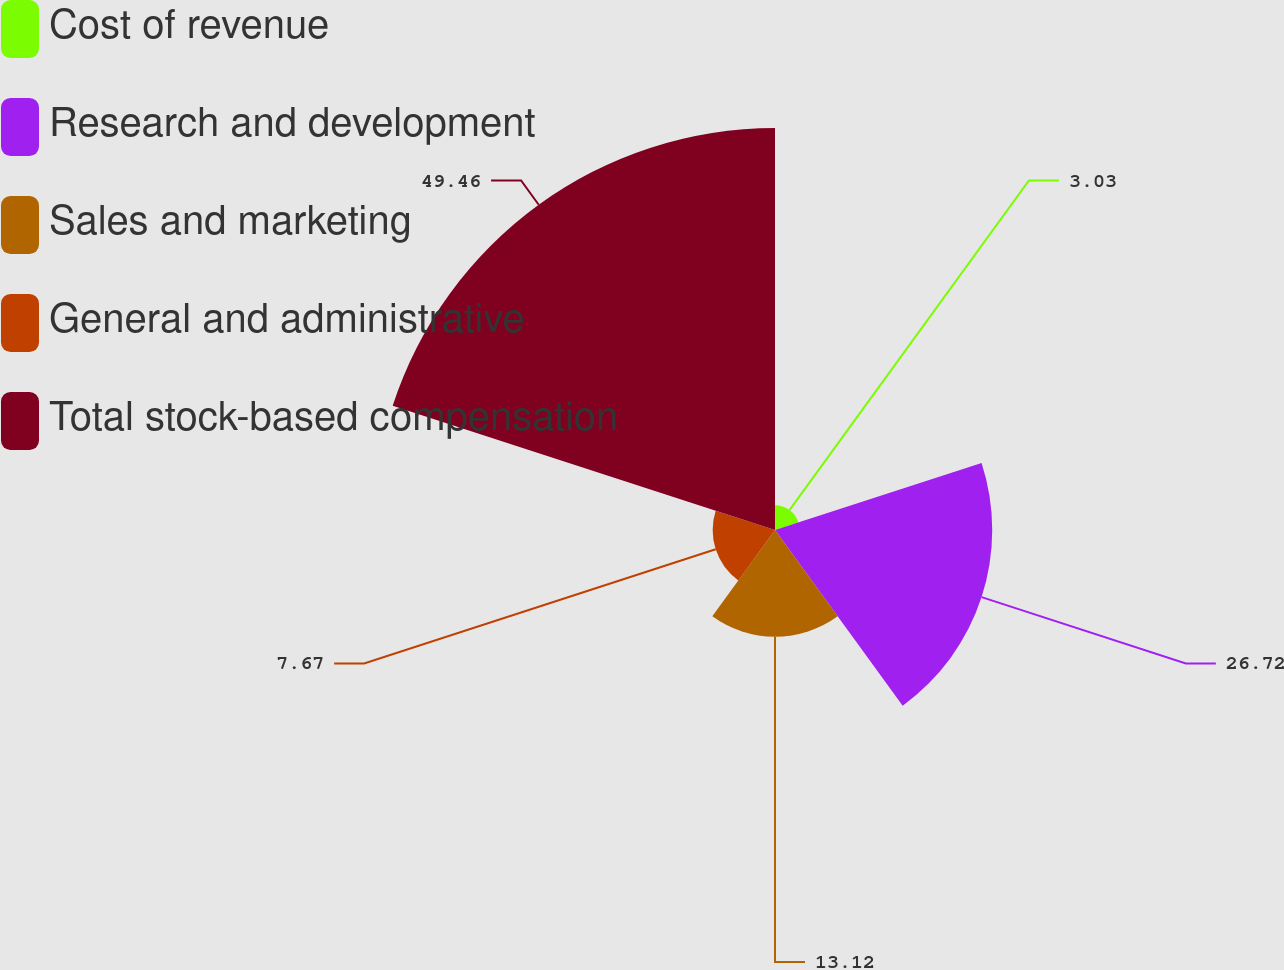Convert chart. <chart><loc_0><loc_0><loc_500><loc_500><pie_chart><fcel>Cost of revenue<fcel>Research and development<fcel>Sales and marketing<fcel>General and administrative<fcel>Total stock-based compensation<nl><fcel>3.03%<fcel>26.72%<fcel>13.12%<fcel>7.67%<fcel>49.45%<nl></chart> 